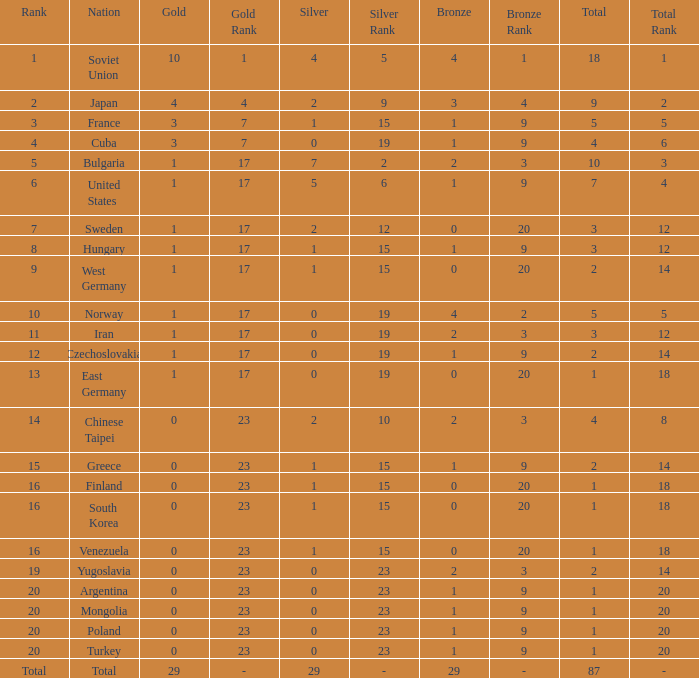What is the average number of bronze medals for total of all nations? 29.0. 